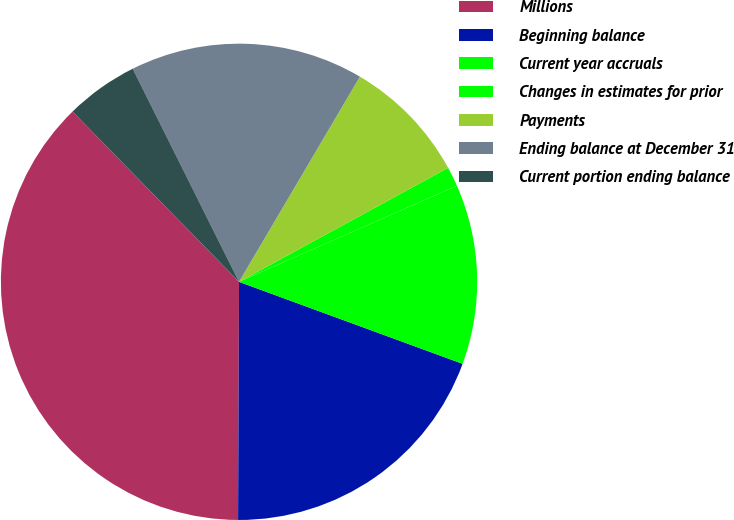Convert chart to OTSL. <chart><loc_0><loc_0><loc_500><loc_500><pie_chart><fcel>Millions<fcel>Beginning balance<fcel>Current year accruals<fcel>Changes in estimates for prior<fcel>Payments<fcel>Ending balance at December 31<fcel>Current portion ending balance<nl><fcel>37.61%<fcel>19.47%<fcel>12.21%<fcel>1.33%<fcel>8.58%<fcel>15.84%<fcel>4.96%<nl></chart> 